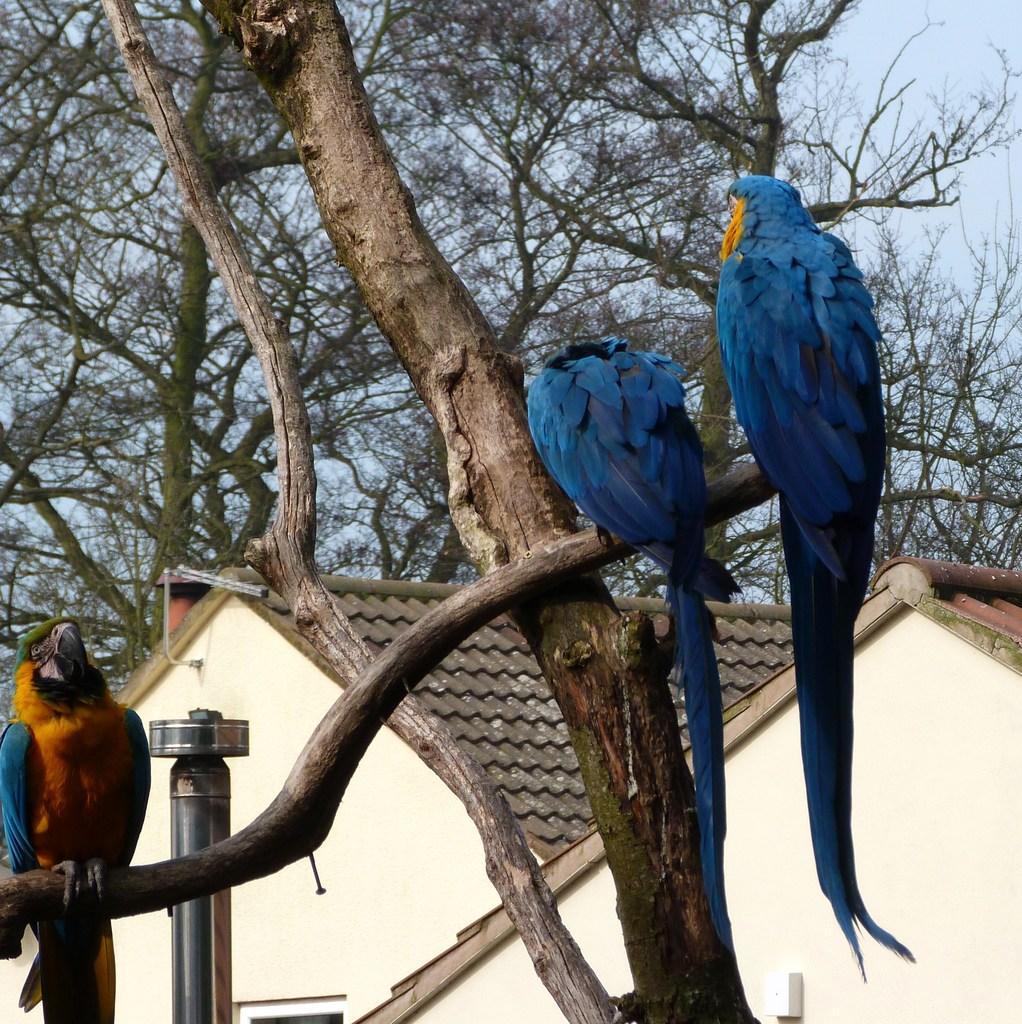Can you describe this image briefly? In this image three birds are standing on the branch of a tree. Left side there is a pole. Behind there are two houses. Background there are few trees and sky. 